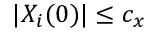<formula> <loc_0><loc_0><loc_500><loc_500>| X _ { i } ( 0 ) | \leq c _ { x }</formula> 